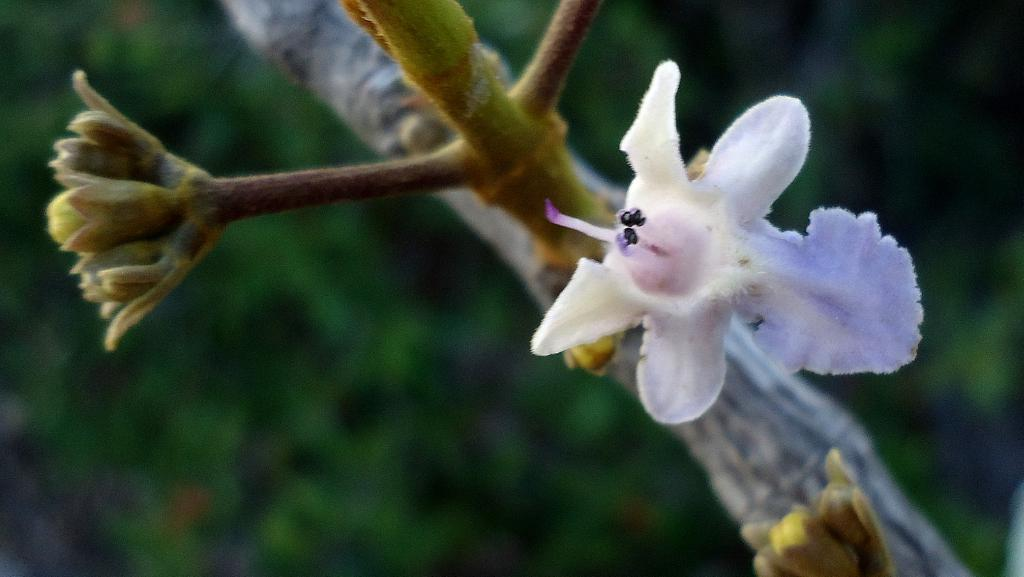What type of plant is visible in the image? There are flowers on the stem of a plant in the image. Can you describe the flowers on the plant? The flowers are visible on the stem of the plant. How many children are playing in the background of the image? There are no children present in the image; it only features a plant with flowers on its stem. 